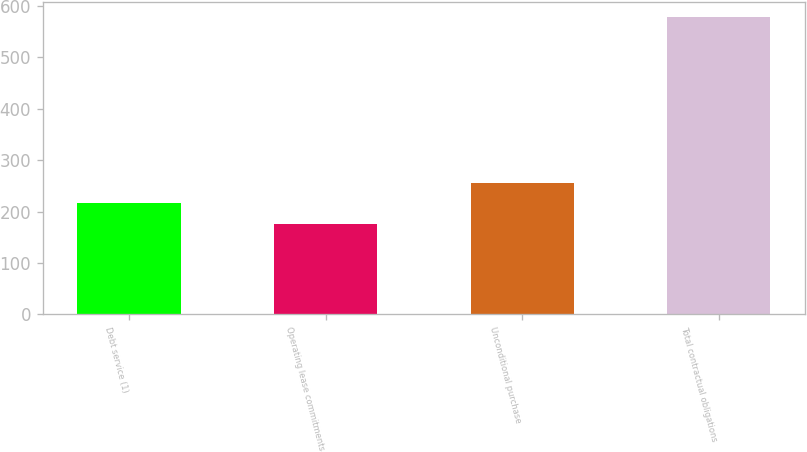<chart> <loc_0><loc_0><loc_500><loc_500><bar_chart><fcel>Debt service (1)<fcel>Operating lease commitments<fcel>Unconditional purchase<fcel>Total contractual obligations<nl><fcel>216.03<fcel>175.7<fcel>256.36<fcel>579<nl></chart> 